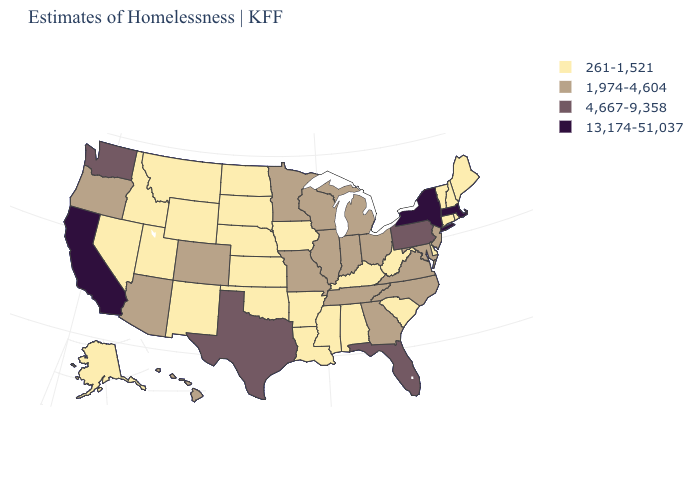Does Wyoming have the same value as Idaho?
Answer briefly. Yes. Name the states that have a value in the range 261-1,521?
Be succinct. Alabama, Alaska, Arkansas, Connecticut, Delaware, Idaho, Iowa, Kansas, Kentucky, Louisiana, Maine, Mississippi, Montana, Nebraska, Nevada, New Hampshire, New Mexico, North Dakota, Oklahoma, Rhode Island, South Carolina, South Dakota, Utah, Vermont, West Virginia, Wyoming. Which states have the lowest value in the USA?
Be succinct. Alabama, Alaska, Arkansas, Connecticut, Delaware, Idaho, Iowa, Kansas, Kentucky, Louisiana, Maine, Mississippi, Montana, Nebraska, Nevada, New Hampshire, New Mexico, North Dakota, Oklahoma, Rhode Island, South Carolina, South Dakota, Utah, Vermont, West Virginia, Wyoming. Does New Jersey have a higher value than South Dakota?
Write a very short answer. Yes. Does the map have missing data?
Answer briefly. No. Among the states that border New Jersey , which have the lowest value?
Answer briefly. Delaware. What is the value of Florida?
Be succinct. 4,667-9,358. Does the map have missing data?
Be succinct. No. What is the value of Virginia?
Quick response, please. 1,974-4,604. Does Oklahoma have the highest value in the South?
Keep it brief. No. Does Arizona have a lower value than Minnesota?
Quick response, please. No. Name the states that have a value in the range 13,174-51,037?
Quick response, please. California, Massachusetts, New York. Name the states that have a value in the range 261-1,521?
Concise answer only. Alabama, Alaska, Arkansas, Connecticut, Delaware, Idaho, Iowa, Kansas, Kentucky, Louisiana, Maine, Mississippi, Montana, Nebraska, Nevada, New Hampshire, New Mexico, North Dakota, Oklahoma, Rhode Island, South Carolina, South Dakota, Utah, Vermont, West Virginia, Wyoming. What is the value of Wisconsin?
Write a very short answer. 1,974-4,604. Name the states that have a value in the range 261-1,521?
Short answer required. Alabama, Alaska, Arkansas, Connecticut, Delaware, Idaho, Iowa, Kansas, Kentucky, Louisiana, Maine, Mississippi, Montana, Nebraska, Nevada, New Hampshire, New Mexico, North Dakota, Oklahoma, Rhode Island, South Carolina, South Dakota, Utah, Vermont, West Virginia, Wyoming. 